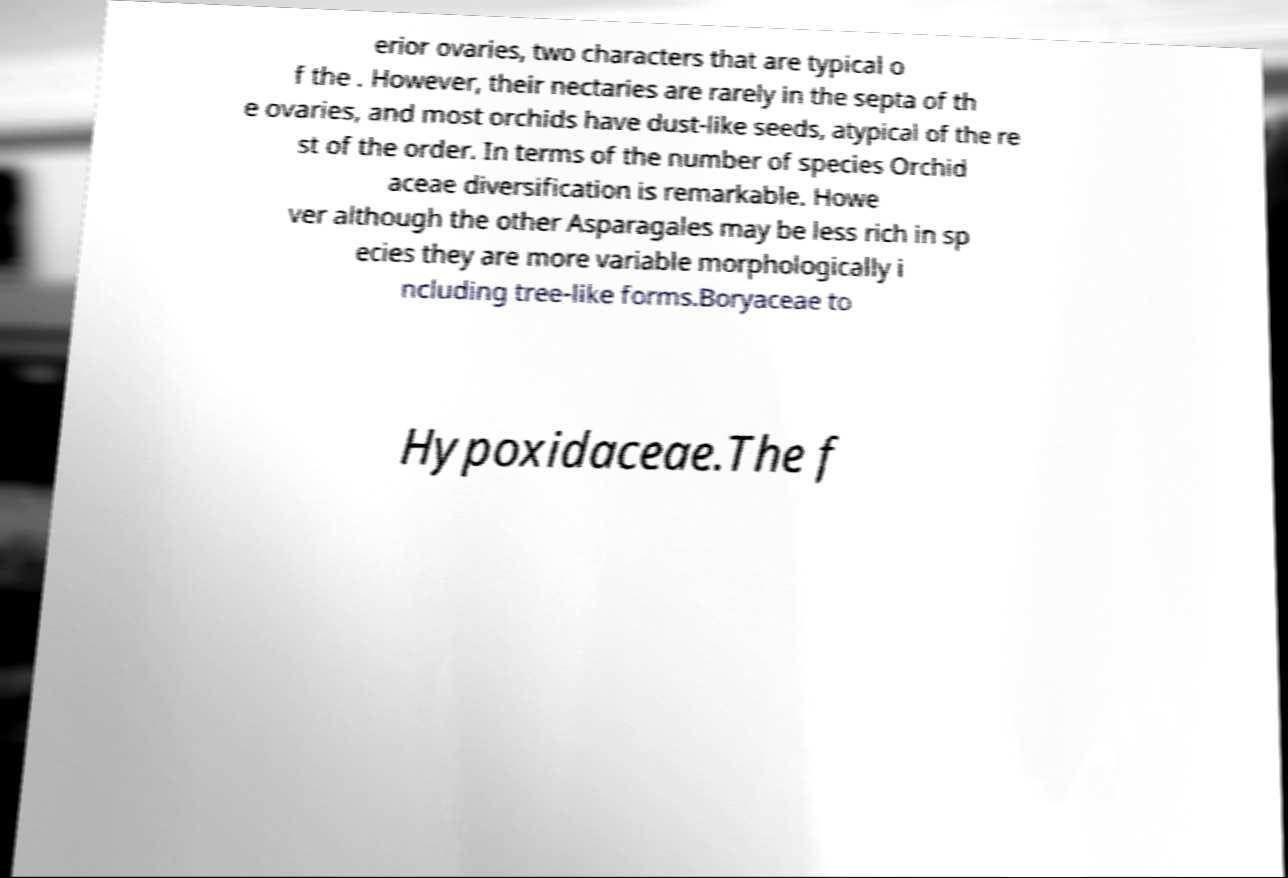Can you read and provide the text displayed in the image?This photo seems to have some interesting text. Can you extract and type it out for me? erior ovaries, two characters that are typical o f the . However, their nectaries are rarely in the septa of th e ovaries, and most orchids have dust-like seeds, atypical of the re st of the order. In terms of the number of species Orchid aceae diversification is remarkable. Howe ver although the other Asparagales may be less rich in sp ecies they are more variable morphologically i ncluding tree-like forms.Boryaceae to Hypoxidaceae.The f 